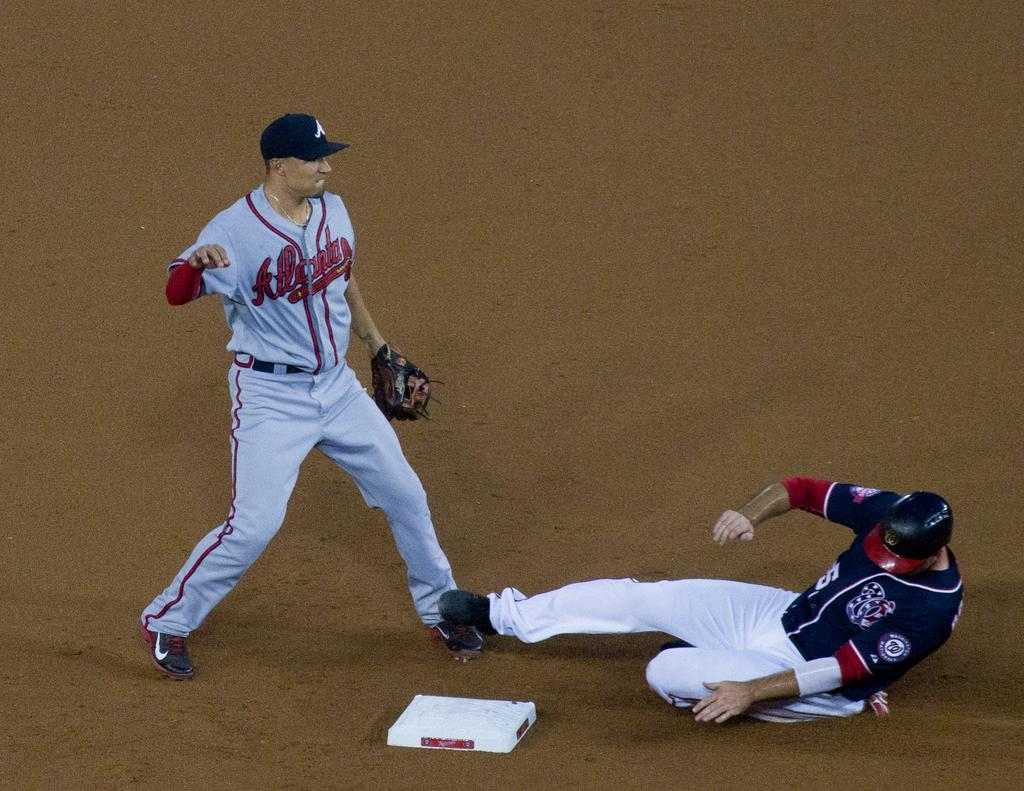<image>
Give a short and clear explanation of the subsequent image. An Atlanta baseball players watches while another player slides to the base. 